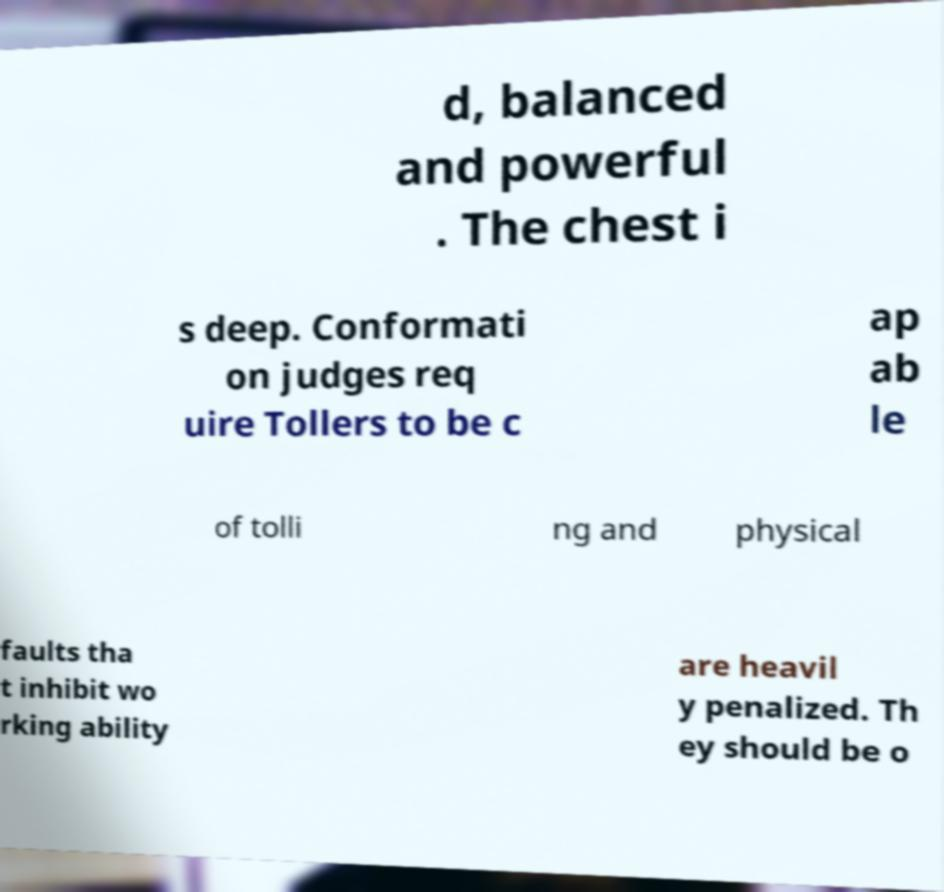Could you assist in decoding the text presented in this image and type it out clearly? d, balanced and powerful . The chest i s deep. Conformati on judges req uire Tollers to be c ap ab le of tolli ng and physical faults tha t inhibit wo rking ability are heavil y penalized. Th ey should be o 